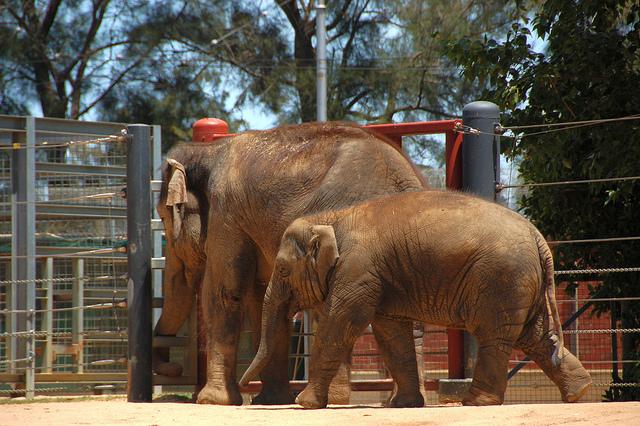What kind of bars?
Write a very short answer. Metal. Which elephant is bigger?
Write a very short answer. One in back. Are the elephants entering their pen?
Keep it brief. Yes. Is one elephant immature?
Keep it brief. Yes. How many horizontal bars?
Quick response, please. 6. 